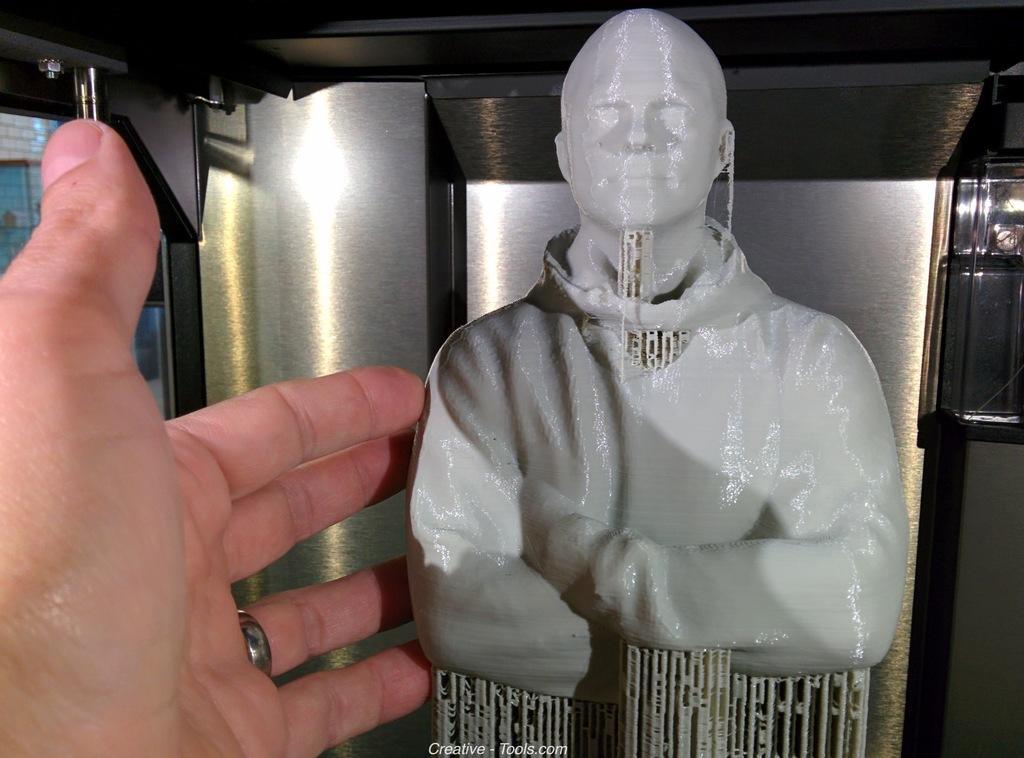Could you give a brief overview of what you see in this image? In this image we can see a statue and a person's hand, in the background, we can see a pillar and the wall. 